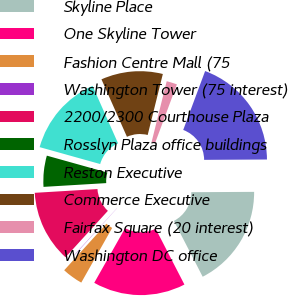Convert chart. <chart><loc_0><loc_0><loc_500><loc_500><pie_chart><fcel>Skyline Place<fcel>One Skyline Tower<fcel>Fashion Centre Mall (75<fcel>Washington Tower (75 interest)<fcel>2200/2300 Courthouse Plaza<fcel>Rosslyn Plaza office buildings<fcel>Reston Executive<fcel>Commerce Executive<fcel>Fairfax Square (20 interest)<fcel>Washington DC office<nl><fcel>17.51%<fcel>15.76%<fcel>3.54%<fcel>0.05%<fcel>12.27%<fcel>5.29%<fcel>14.02%<fcel>10.52%<fcel>1.79%<fcel>19.25%<nl></chart> 